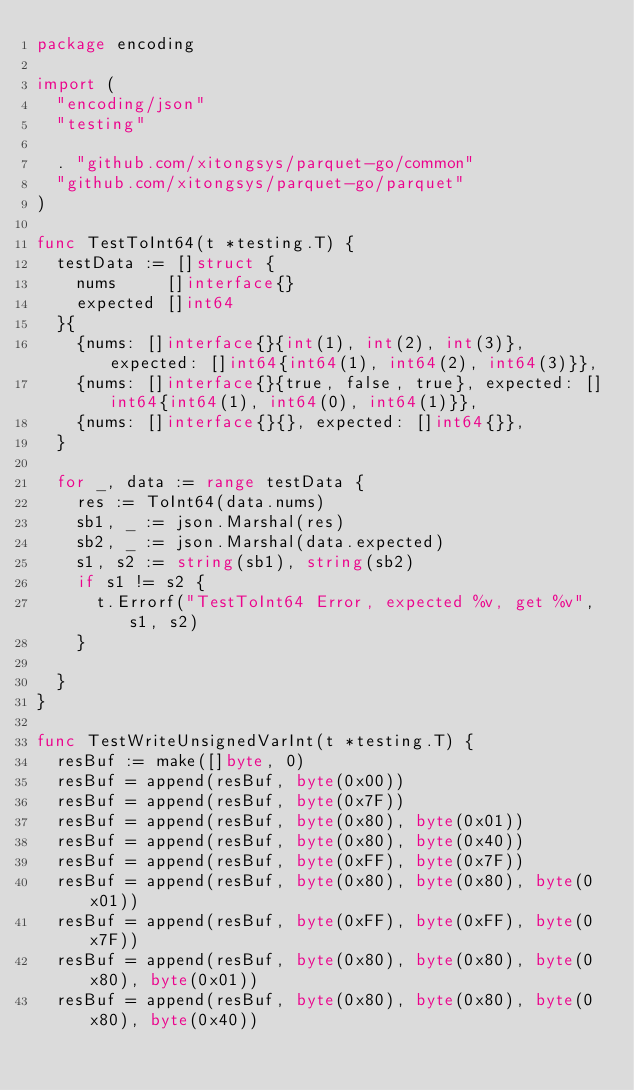<code> <loc_0><loc_0><loc_500><loc_500><_Go_>package encoding

import (
	"encoding/json"
	"testing"

	. "github.com/xitongsys/parquet-go/common"
	"github.com/xitongsys/parquet-go/parquet"
)

func TestToInt64(t *testing.T) {
	testData := []struct {
		nums     []interface{}
		expected []int64
	}{
		{nums: []interface{}{int(1), int(2), int(3)}, expected: []int64{int64(1), int64(2), int64(3)}},
		{nums: []interface{}{true, false, true}, expected: []int64{int64(1), int64(0), int64(1)}},
		{nums: []interface{}{}, expected: []int64{}},
	}

	for _, data := range testData {
		res := ToInt64(data.nums)
		sb1, _ := json.Marshal(res)
		sb2, _ := json.Marshal(data.expected)
		s1, s2 := string(sb1), string(sb2)
		if s1 != s2 {
			t.Errorf("TestToInt64 Error, expected %v, get %v", s1, s2)
		}

	}
}

func TestWriteUnsignedVarInt(t *testing.T) {
	resBuf := make([]byte, 0)
	resBuf = append(resBuf, byte(0x00))
	resBuf = append(resBuf, byte(0x7F))
	resBuf = append(resBuf, byte(0x80), byte(0x01))
	resBuf = append(resBuf, byte(0x80), byte(0x40))
	resBuf = append(resBuf, byte(0xFF), byte(0x7F))
	resBuf = append(resBuf, byte(0x80), byte(0x80), byte(0x01))
	resBuf = append(resBuf, byte(0xFF), byte(0xFF), byte(0x7F))
	resBuf = append(resBuf, byte(0x80), byte(0x80), byte(0x80), byte(0x01))
	resBuf = append(resBuf, byte(0x80), byte(0x80), byte(0x80), byte(0x40))</code> 